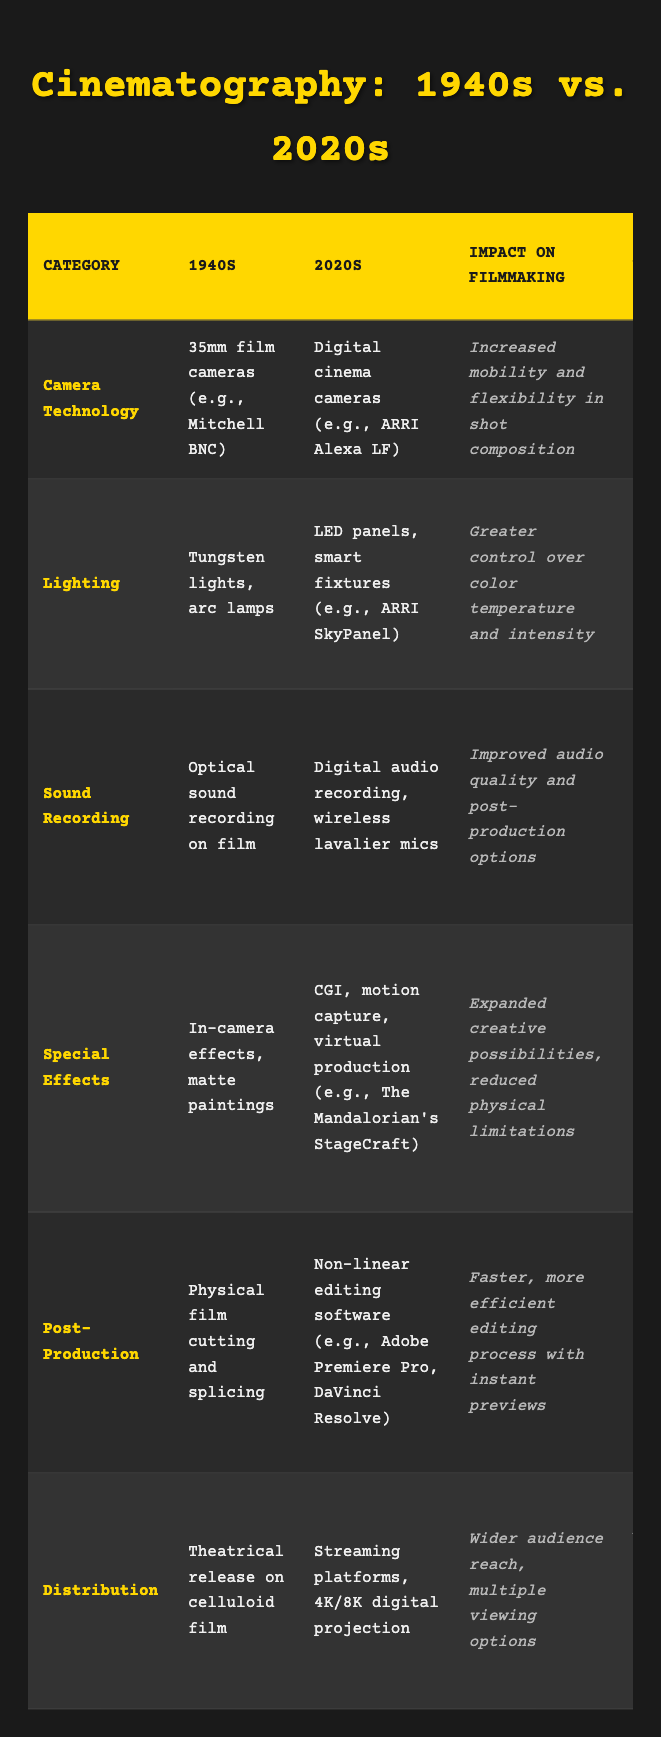What type of sound recording technology was used in the 1940s? According to the table, the sound recording technology in the 1940s was "Optical sound recording on film."
Answer: Optical sound recording on film Which lighting technology used in the 2020s allows for greater control over color temperature? The table indicates that "LED panels, smart fixtures (e.g., ARRI SkyPanel)" are the lighting technologies in the 2020s that provide greater control over color temperature and intensity.
Answer: LED panels, smart fixtures What is the major difference in special effects technology between the 1940s and 2020s? The table shows that in the 1940s, special effects relied on "In-camera effects, matte paintings," while in the 2020s, technology includes "CGI, motion capture, virtual production." This signifies a shift from physical effects to digital enhancements.
Answer: Shift from physical effects to digital enhancements Is digital audio recording present in the 1940s technology category? The table clearly states that the sound recording in the 1940s was "Optical sound recording on film," indicating that digital audio recording was not available then.
Answer: No What impact did the advancements in camera technology from the 1940s to the 2020s have on filmmaking flexibility? The table notes that the impact of camera technology has led to "Increased mobility and flexibility in shot composition," showing that modern technology allows for more dynamic filming than in the past.
Answer: Increased mobility and flexibility How does the ability to create layered soundscapes compare between the two eras? In the 1940s, filmmakers relied on optical sound recording, while the 2020s introduced digital audio recording with wireless mics. According to the table, this change has led to "Improved audio quality and post-production options," reflecting a significant advancement in sound complexity.
Answer: Greater sound complexity in 2020s Which area of filmmaking saw the most substantial change in the means of editing from the 1940s to the 2020s? The table highlights that editing in the 1940s involved "Physical film cutting and splicing," while the 2020s utilize software for non-linear editing, indicating a significant transformation in editing processes and efficiency.
Answer: Substantial change in editing processes What relevance do modern distribution methods have to experimentation in filmmaking? The table states that the 2020s include "Streaming platforms" which provide "Wider audience reach, multiple viewing options." This allows filmmakers to explore experimental formats similarly to Welles' later works, suggesting a more diverse distribution landscape today.
Answer: Expanded experimental formats 